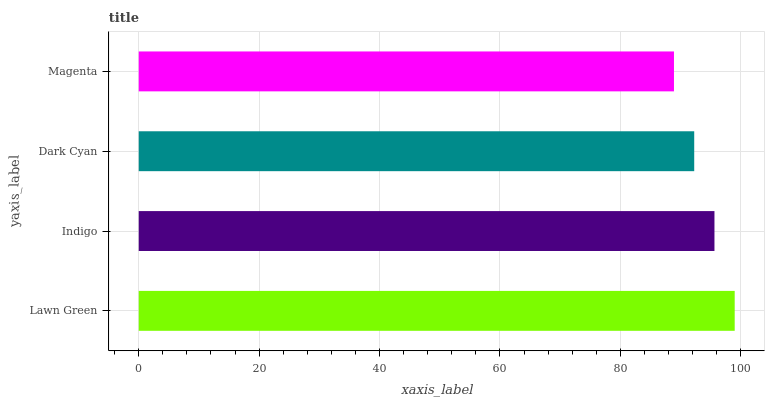Is Magenta the minimum?
Answer yes or no. Yes. Is Lawn Green the maximum?
Answer yes or no. Yes. Is Indigo the minimum?
Answer yes or no. No. Is Indigo the maximum?
Answer yes or no. No. Is Lawn Green greater than Indigo?
Answer yes or no. Yes. Is Indigo less than Lawn Green?
Answer yes or no. Yes. Is Indigo greater than Lawn Green?
Answer yes or no. No. Is Lawn Green less than Indigo?
Answer yes or no. No. Is Indigo the high median?
Answer yes or no. Yes. Is Dark Cyan the low median?
Answer yes or no. Yes. Is Magenta the high median?
Answer yes or no. No. Is Indigo the low median?
Answer yes or no. No. 